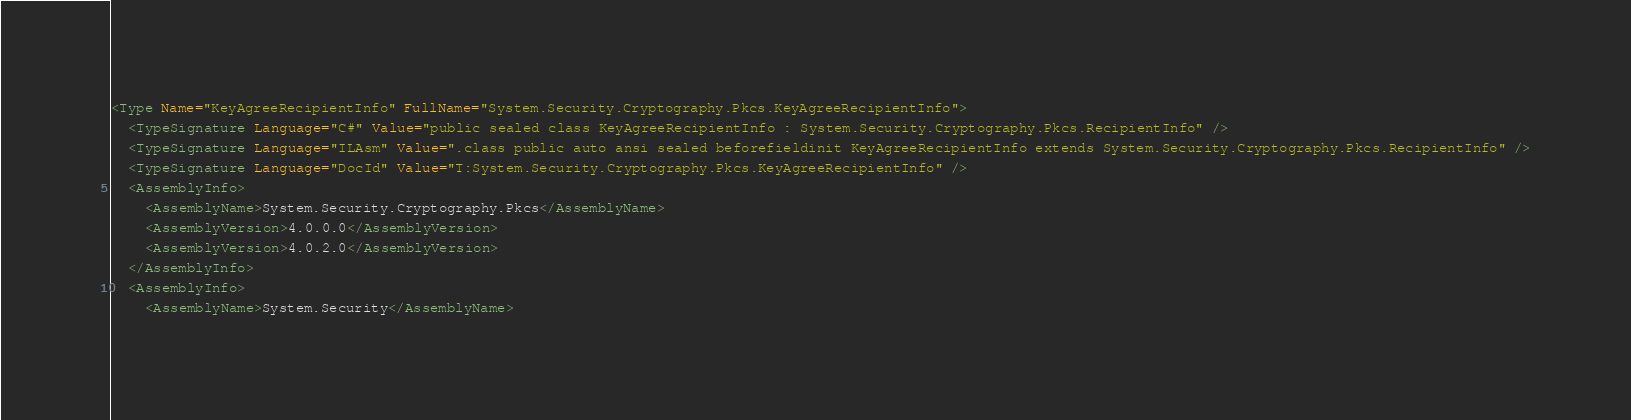<code> <loc_0><loc_0><loc_500><loc_500><_XML_><Type Name="KeyAgreeRecipientInfo" FullName="System.Security.Cryptography.Pkcs.KeyAgreeRecipientInfo">
  <TypeSignature Language="C#" Value="public sealed class KeyAgreeRecipientInfo : System.Security.Cryptography.Pkcs.RecipientInfo" />
  <TypeSignature Language="ILAsm" Value=".class public auto ansi sealed beforefieldinit KeyAgreeRecipientInfo extends System.Security.Cryptography.Pkcs.RecipientInfo" />
  <TypeSignature Language="DocId" Value="T:System.Security.Cryptography.Pkcs.KeyAgreeRecipientInfo" />
  <AssemblyInfo>
    <AssemblyName>System.Security.Cryptography.Pkcs</AssemblyName>
    <AssemblyVersion>4.0.0.0</AssemblyVersion>
    <AssemblyVersion>4.0.2.0</AssemblyVersion>
  </AssemblyInfo>
  <AssemblyInfo>
    <AssemblyName>System.Security</AssemblyName></code> 